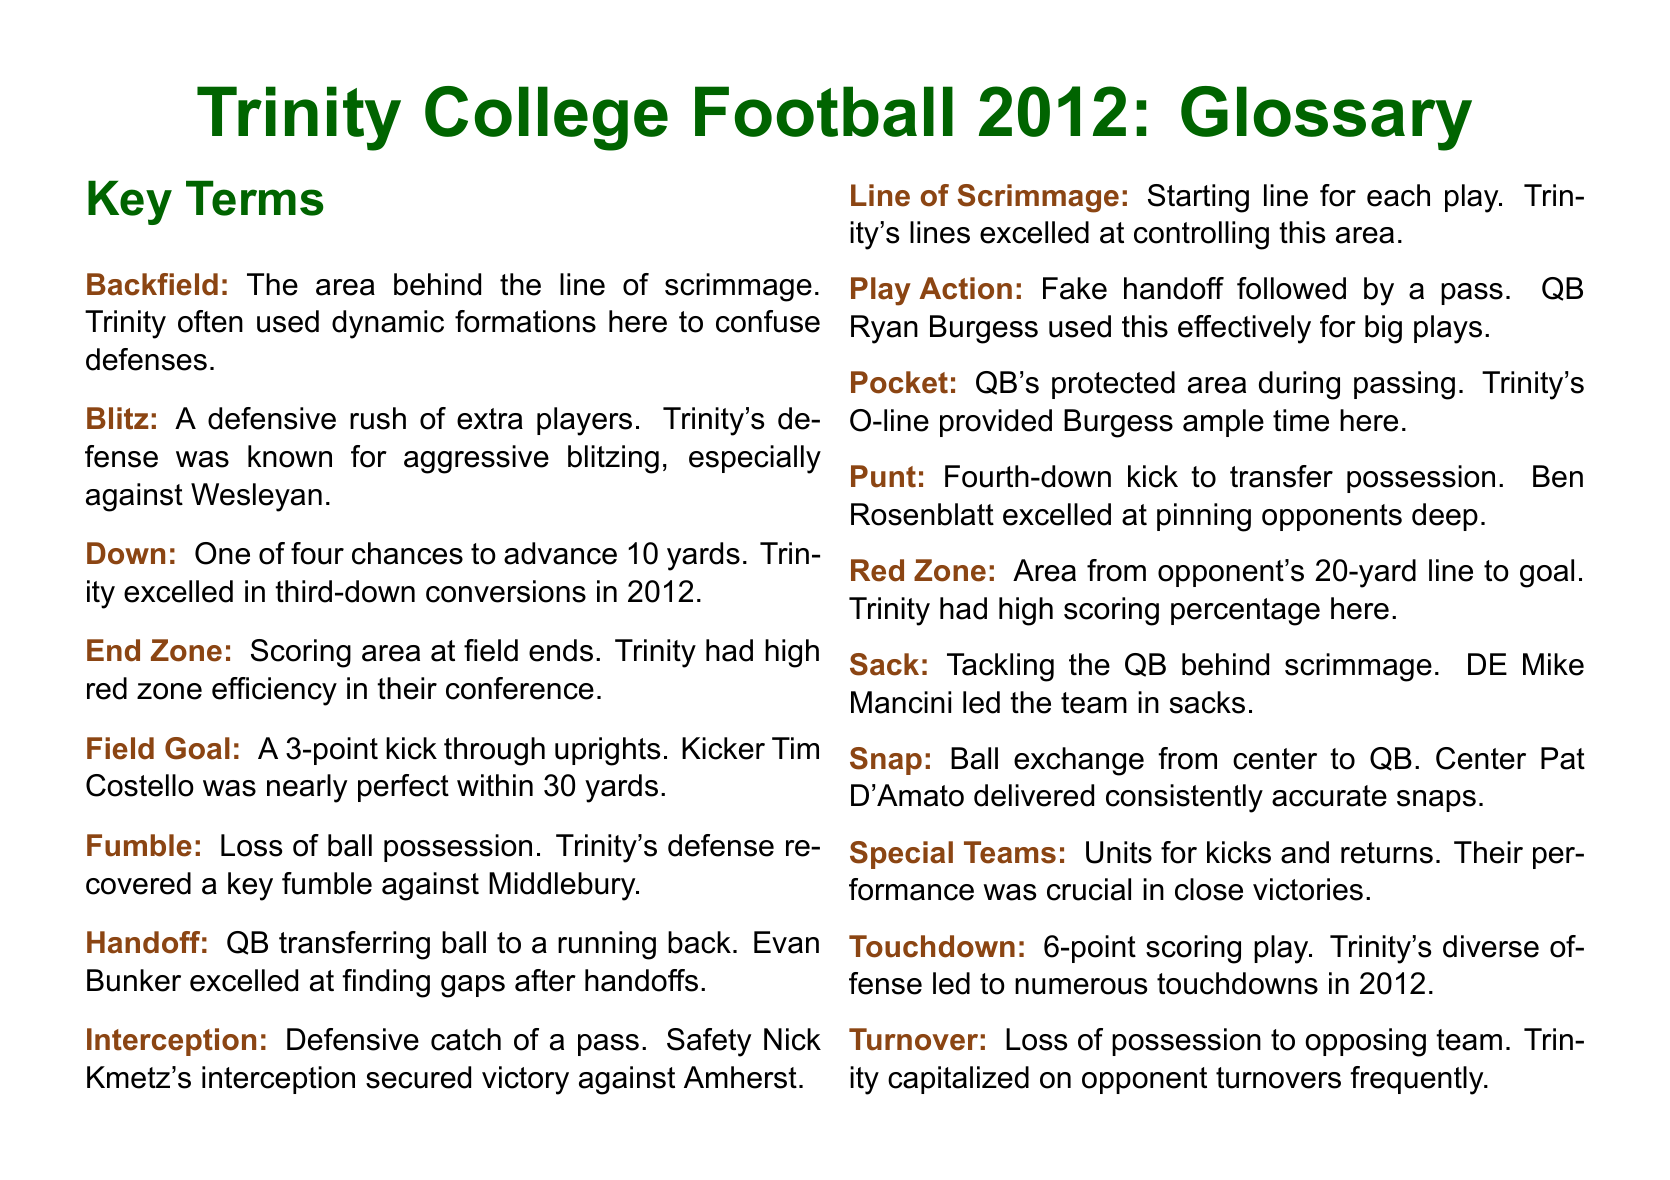what is the scoring area at field ends? The scoring area at field ends is referred to in the document as the End Zone.
Answer: End Zone who was Trinity's kicker during the 2012 season? The document mentions Tim Costello as the kicker who was nearly perfect within 30 yards.
Answer: Tim Costello how many points is a touchdown worth? The document states that a touchdown is a 6-point scoring play.
Answer: 6 which player led the team in sacks? The document indicates that DE Mike Mancini led the team in sacks during the 2012 season.
Answer: Mike Mancini what does a team aim to achieve on third down? The document mentions that Trinity excelled in converting opportunities on third down, aiming to advance 10 yards.
Answer: Advance 10 yards what term is used for the area behind the line of scrimmage? The area behind the line of scrimmage is referred to as the Backfield in the document.
Answer: Backfield how many yards must a team advance for a new set of downs? The document specifies that a team must advance 10 yards for a new set of downs.
Answer: 10 yards what is the term for a defensive rush of extra players? The document defines this action as a Blitz.
Answer: Blitz 